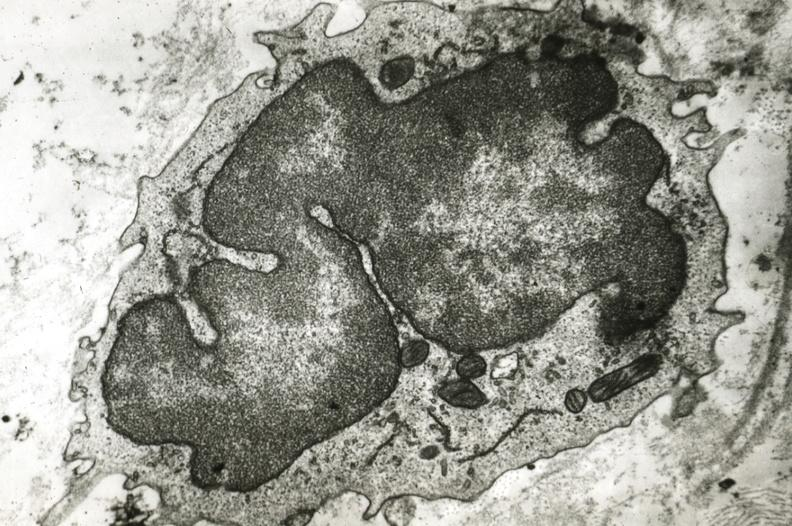what is present?
Answer the question using a single word or phrase. Vasculature 